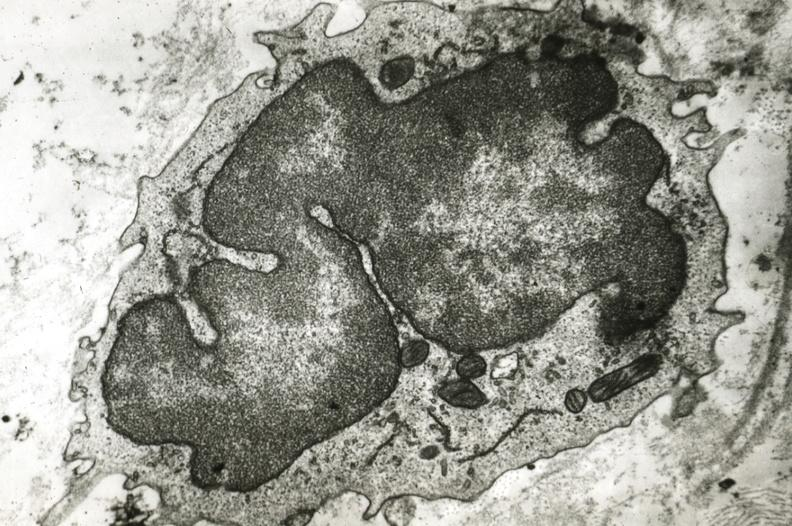what is present?
Answer the question using a single word or phrase. Vasculature 